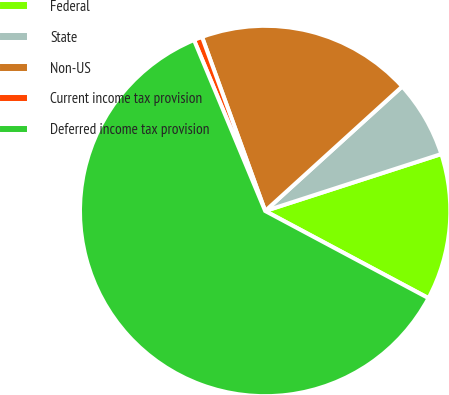Convert chart to OTSL. <chart><loc_0><loc_0><loc_500><loc_500><pie_chart><fcel>Federal<fcel>State<fcel>Non-US<fcel>Current income tax provision<fcel>Deferred income tax provision<nl><fcel>12.78%<fcel>6.76%<fcel>18.8%<fcel>0.74%<fcel>60.92%<nl></chart> 